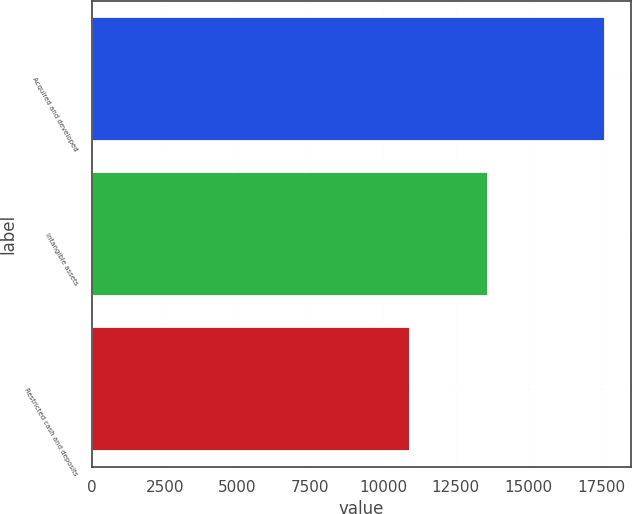Convert chart to OTSL. <chart><loc_0><loc_0><loc_500><loc_500><bar_chart><fcel>Acquired and developed<fcel>Intangible assets<fcel>Restricted cash and deposits<nl><fcel>17641<fcel>13618<fcel>10927<nl></chart> 